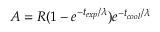<formula> <loc_0><loc_0><loc_500><loc_500>A = R ( 1 - e ^ { - t _ { e x p } / \lambda } ) e ^ { - t _ { c o o l } / \lambda }</formula> 